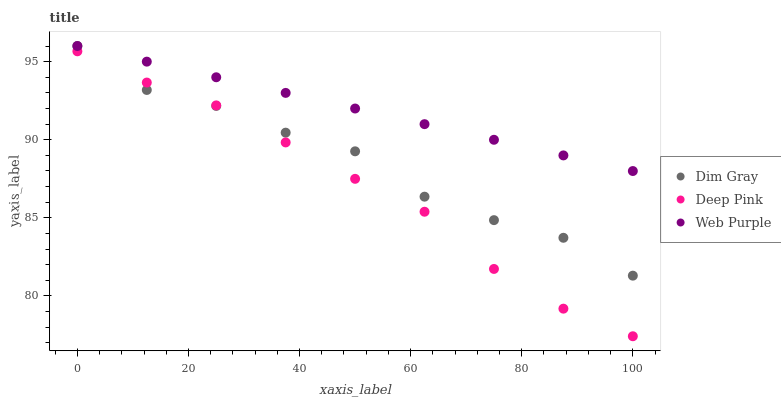Does Deep Pink have the minimum area under the curve?
Answer yes or no. Yes. Does Web Purple have the maximum area under the curve?
Answer yes or no. Yes. Does Dim Gray have the minimum area under the curve?
Answer yes or no. No. Does Dim Gray have the maximum area under the curve?
Answer yes or no. No. Is Web Purple the smoothest?
Answer yes or no. Yes. Is Dim Gray the roughest?
Answer yes or no. Yes. Is Deep Pink the smoothest?
Answer yes or no. No. Is Deep Pink the roughest?
Answer yes or no. No. Does Deep Pink have the lowest value?
Answer yes or no. Yes. Does Dim Gray have the lowest value?
Answer yes or no. No. Does Dim Gray have the highest value?
Answer yes or no. Yes. Does Deep Pink have the highest value?
Answer yes or no. No. Is Deep Pink less than Web Purple?
Answer yes or no. Yes. Is Web Purple greater than Deep Pink?
Answer yes or no. Yes. Does Deep Pink intersect Dim Gray?
Answer yes or no. Yes. Is Deep Pink less than Dim Gray?
Answer yes or no. No. Is Deep Pink greater than Dim Gray?
Answer yes or no. No. Does Deep Pink intersect Web Purple?
Answer yes or no. No. 